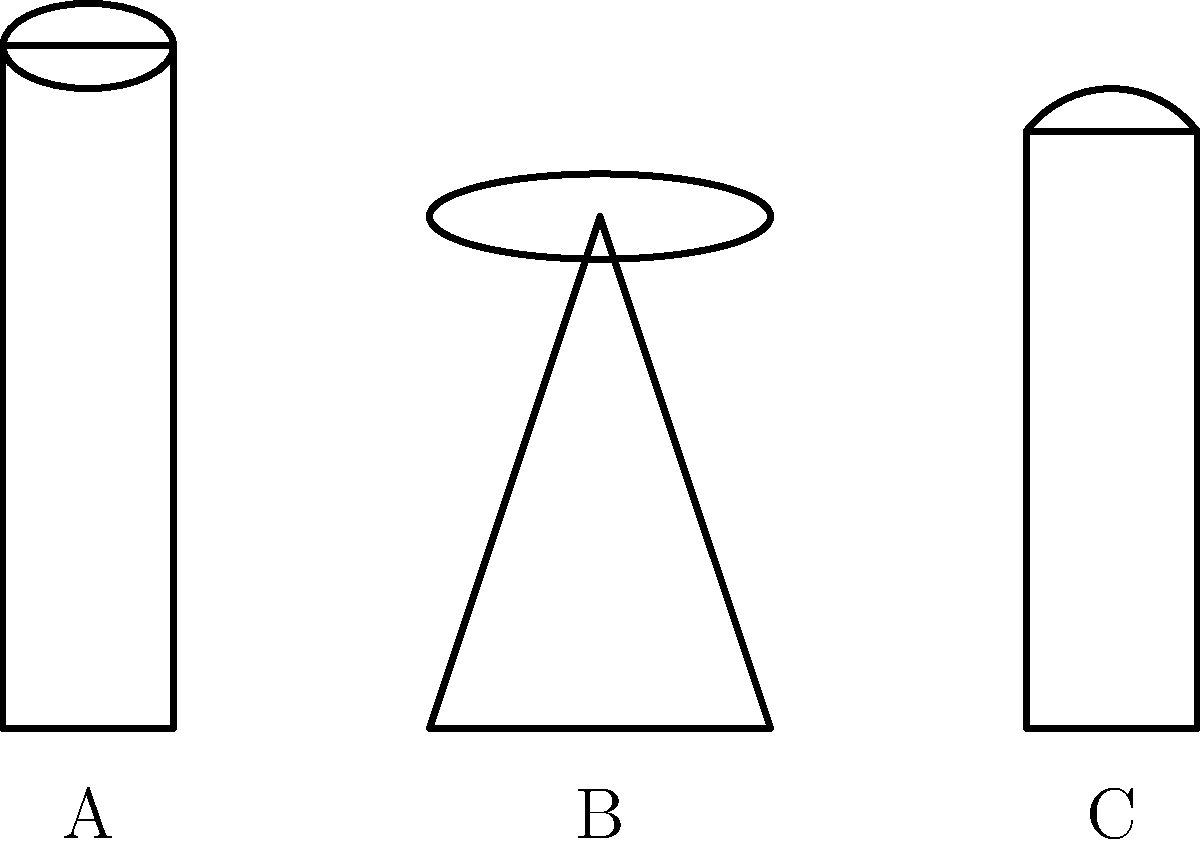Look at the simple line drawings above, labeled A, B, and C. Which of these objects is most commonly associated with stand-up comedy performances? Let's analyze each object in the drawing:

1. Object A: This appears to be a microphone. It has a long handle and a round top, which is characteristic of a typical stage microphone.

2. Object B: This looks like a stool or a high chair. It has three legs and a round seat.

3. Object C: This resembles a water bottle. It has a cylindrical shape with a slightly curved top.

Now, let's consider which of these is most commonly associated with stand-up comedy:

1. Microphones are essential for stand-up comedy as they amplify the comedian's voice, allowing the audience to hear clearly.

2. Stools are often used by stand-up comedians to sit on or lean against during their performance, providing a casual and intimate atmosphere.

3. Water bottles, while possibly present, are not distinctively associated with stand-up comedy.

Among these three, the microphone (Object A) is the most iconic and necessary tool for stand-up comedy. It's practically impossible to imagine a stand-up performance without a microphone, as it's crucial for the audience to hear the comedian's jokes and stories.
Answer: A (Microphone) 